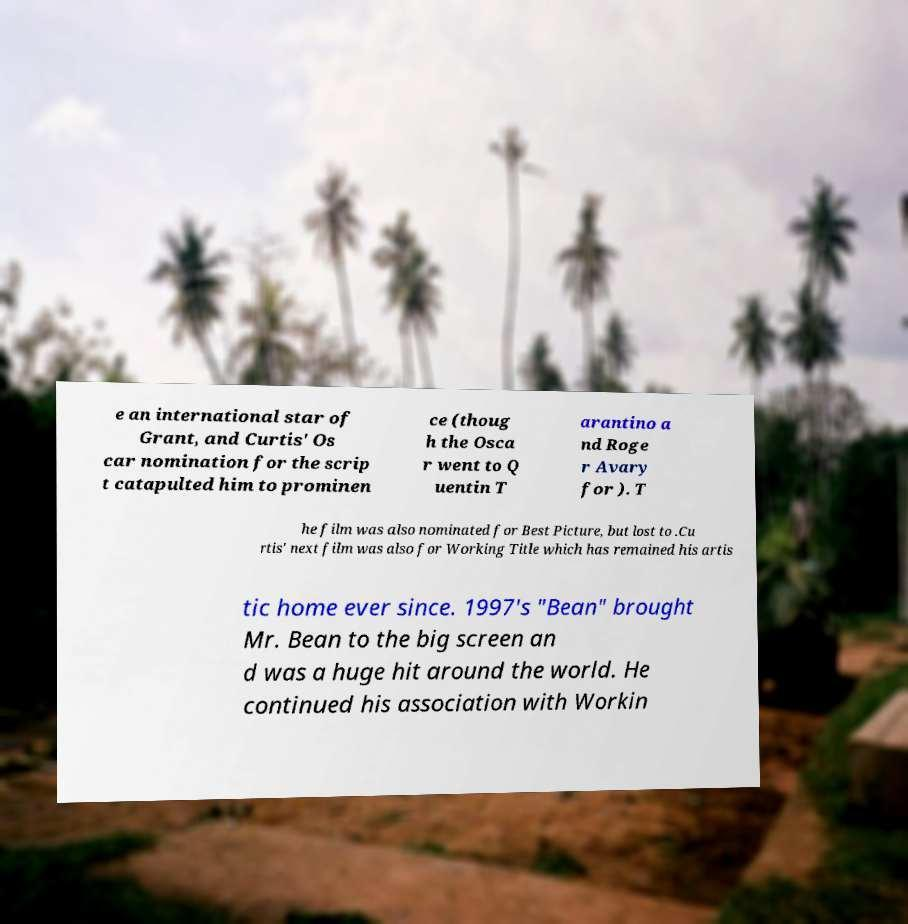For documentation purposes, I need the text within this image transcribed. Could you provide that? e an international star of Grant, and Curtis' Os car nomination for the scrip t catapulted him to prominen ce (thoug h the Osca r went to Q uentin T arantino a nd Roge r Avary for ). T he film was also nominated for Best Picture, but lost to .Cu rtis' next film was also for Working Title which has remained his artis tic home ever since. 1997's "Bean" brought Mr. Bean to the big screen an d was a huge hit around the world. He continued his association with Workin 